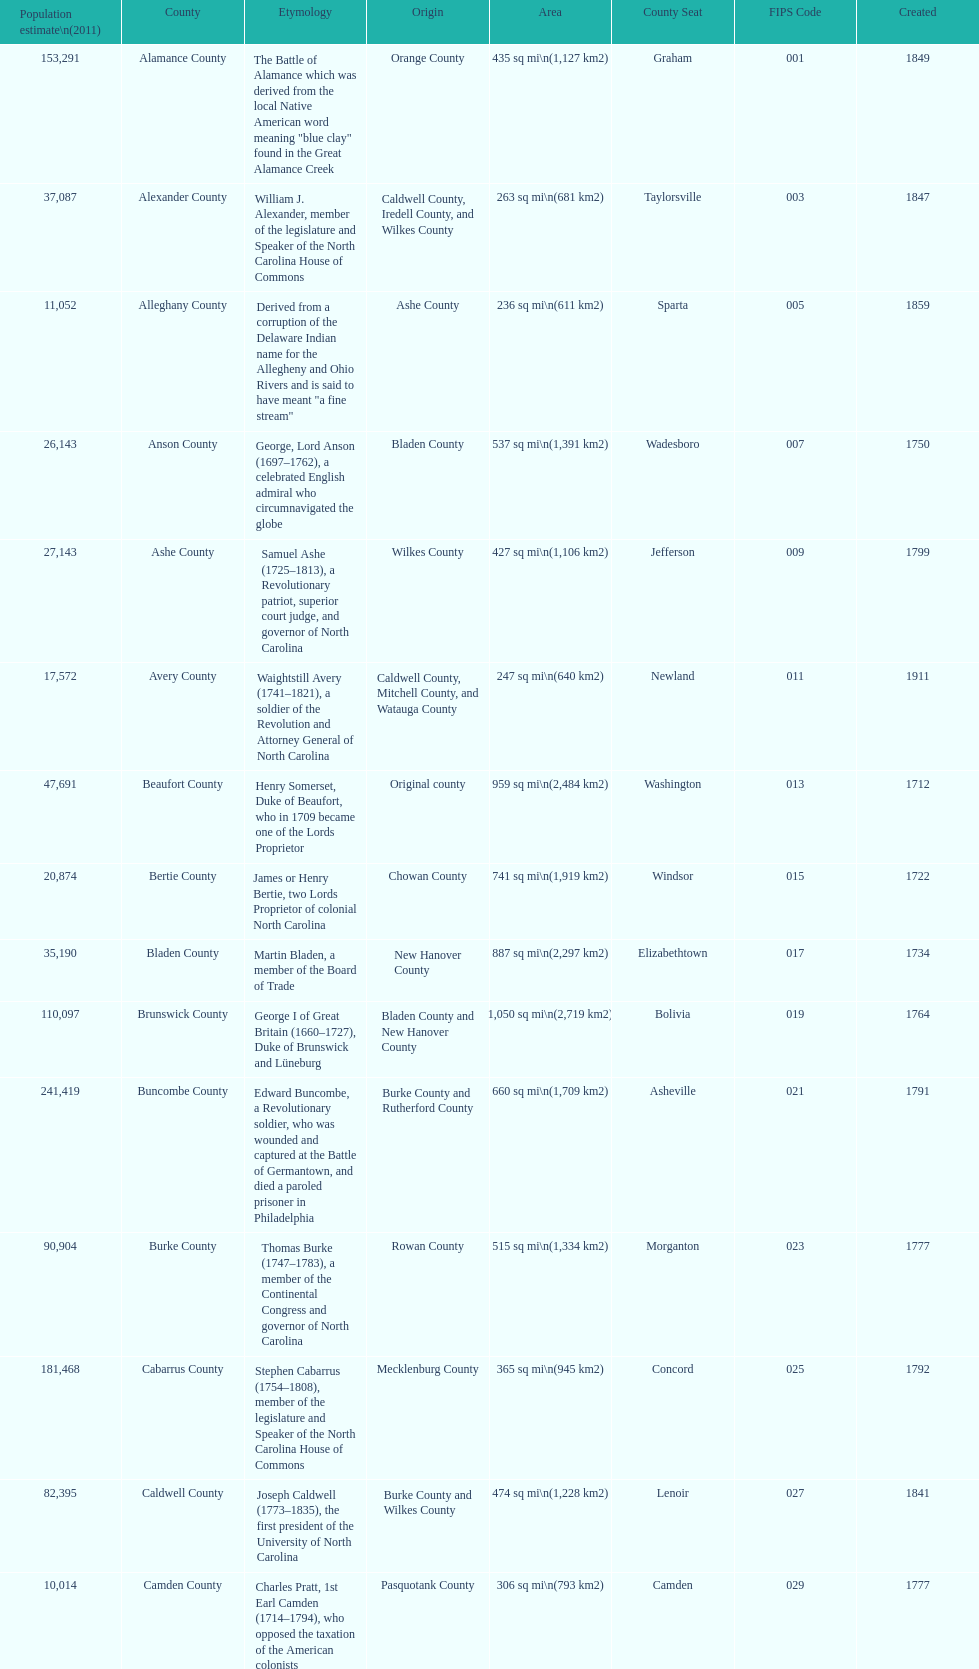Which county covers the most area? Dare County. 